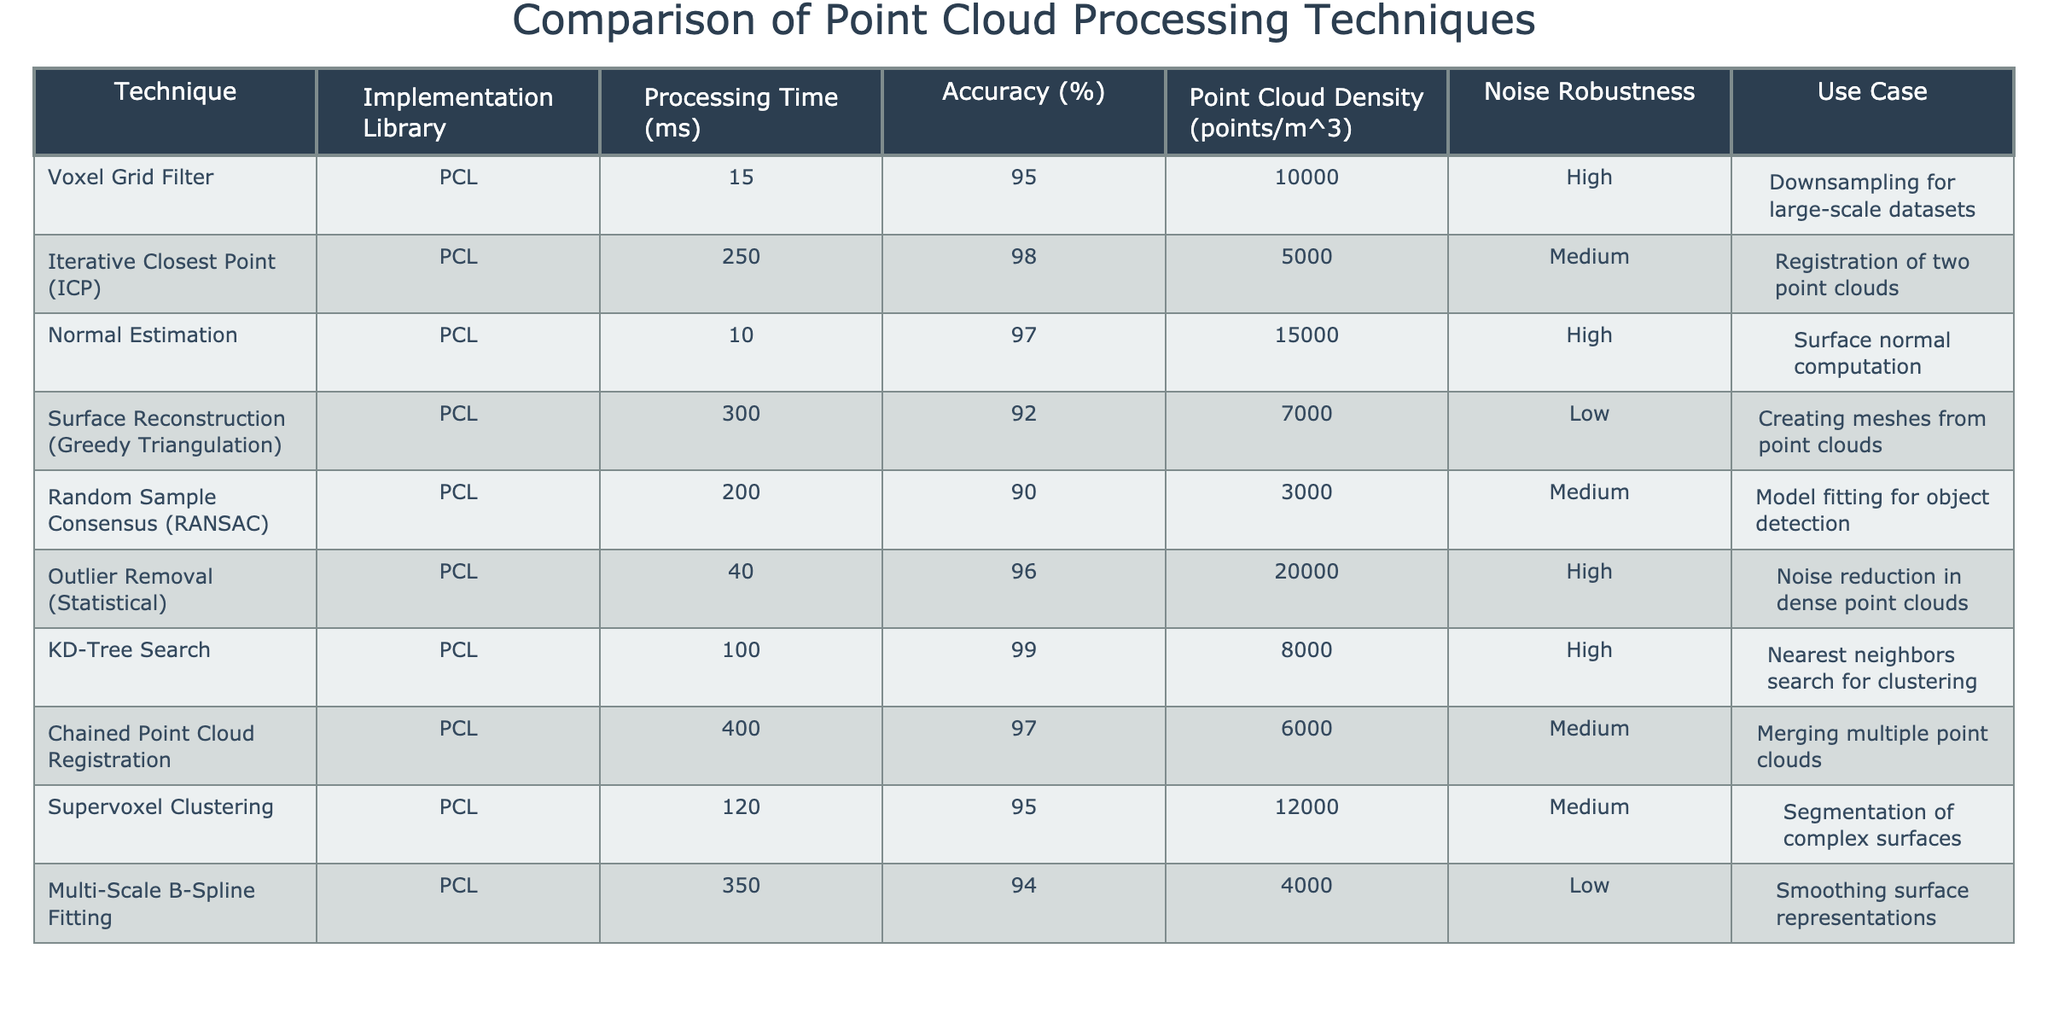What is the processing time of the Voxel Grid Filter? The Voxel Grid Filter technique has a processing time of 15 milliseconds, which is listed in the table under the "Processing Time (ms)" column.
Answer: 15 ms Which point processing technique has the highest accuracy? The Iterative Closest Point (ICP) technique has the highest accuracy at 98%, as seen in the "Accuracy (%)" column.
Answer: 98% Is the Surface Reconstruction technique more or less noise robust compared to the KD-Tree Search? The Surface Reconstruction (Greedy Triangulation) technique has low noise robustness, while the KD-Tree Search technique has high noise robustness. Therefore, the Surface Reconstruction technique is less noise robust.
Answer: Less What is the average Point Cloud Density for techniques with high noise robustness? The techniques with high noise robustness are Voxel Grid Filter, Normal Estimation, Outlier Removal, and KD-Tree Search. Their densities are 10000, 15000, 20000, and 8000 respectively. The average is (10000 + 15000 + 20000 + 8000) / 4 = 13250 points/m^3.
Answer: 13250 points/m^3 Which technique has the longest processing time and what is that time? The Chained Point Cloud Registration technique has the longest processing time at 400 milliseconds, as listed in the "Processing Time (ms)" column.
Answer: 400 ms True or False: The Random Sample Consensus technique has a higher accuracy than the Outlier Removal technique. The accuracy for Random Sample Consensus is 90% and for Outlier Removal, it is 96%. Since 90% is less than 96%, the statement is false.
Answer: False How many techniques have an accuracy of 95% or higher? The techniques with 95% or higher accuracy are Voxel Grid Filter (95%), ICP (98%), Normal Estimation (97%), Outlier Removal (96%), KD-Tree Search (99%), and Supervoxel Clustering (95%). That totals to 6 techniques.
Answer: 6 What technique has a Point Cloud Density of 3000 points/m^3 and what is its processing time? The Random Sample Consensus technique has a Point Cloud Density of 3000 points/m^3, and its processing time is 200 milliseconds, which can be found under the respective columns in the table.
Answer: 200 ms Which technique is best suited for deep surface noise reduction, based on robustness against noise? The Outlier Removal (Statistical) technique is best suited for deep surface noise reduction as it is indicated to be highly robust against noise.
Answer: Outlier Removal (Statistical) What is the total processing time of the techniques with low robustness? The techniques with low noise robustness are Surface Reconstruction (Greedy Triangulation) and Multi-Scale B-Spline Fitting, with respective processing times of 300 ms and 350 ms. The total processing time is 300 + 350 = 650 milliseconds.
Answer: 650 ms 